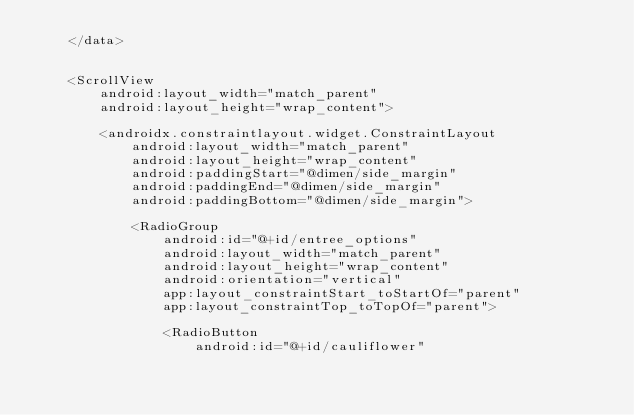Convert code to text. <code><loc_0><loc_0><loc_500><loc_500><_XML_>    </data>


    <ScrollView
        android:layout_width="match_parent"
        android:layout_height="wrap_content">

        <androidx.constraintlayout.widget.ConstraintLayout
            android:layout_width="match_parent"
            android:layout_height="wrap_content"
            android:paddingStart="@dimen/side_margin"
            android:paddingEnd="@dimen/side_margin"
            android:paddingBottom="@dimen/side_margin">

            <RadioGroup
                android:id="@+id/entree_options"
                android:layout_width="match_parent"
                android:layout_height="wrap_content"
                android:orientation="vertical"
                app:layout_constraintStart_toStartOf="parent"
                app:layout_constraintTop_toTopOf="parent">

                <RadioButton
                    android:id="@+id/cauliflower"</code> 